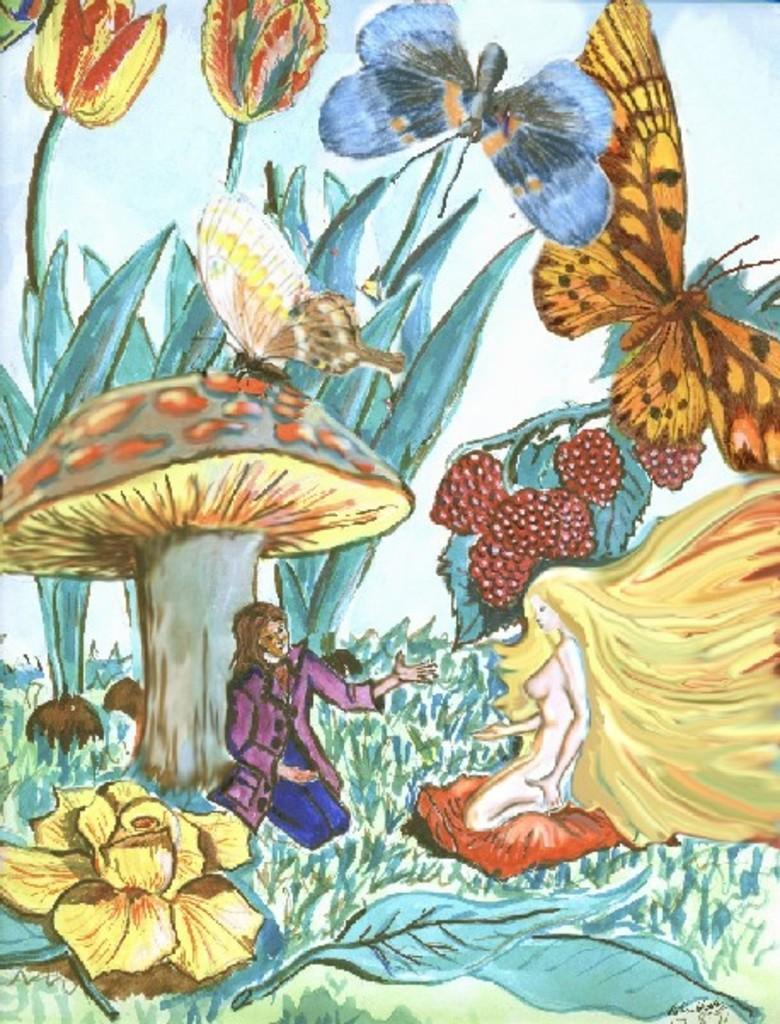Please provide a concise description of this image. This is a painting. Here we can see two persons, leaves, flowers, plants, and butterflies. 